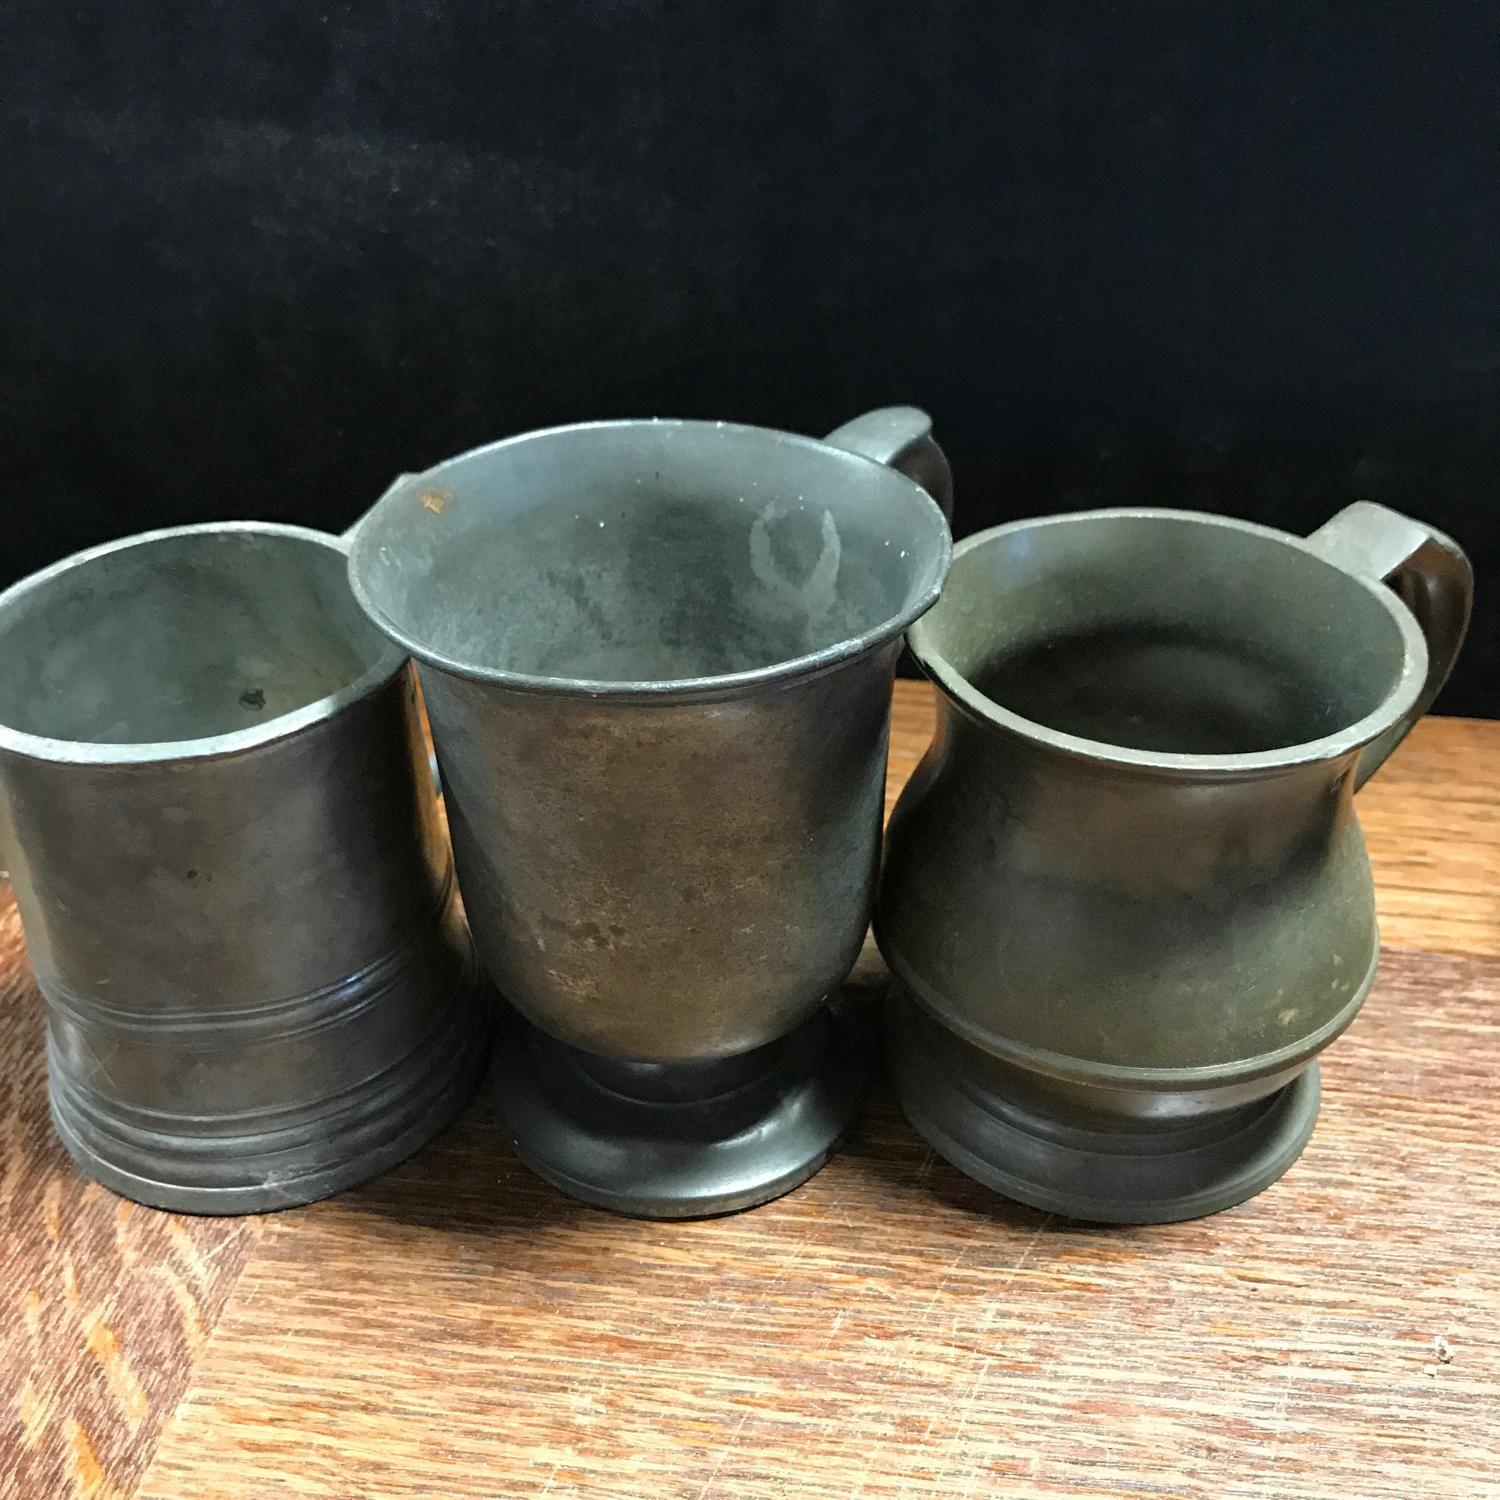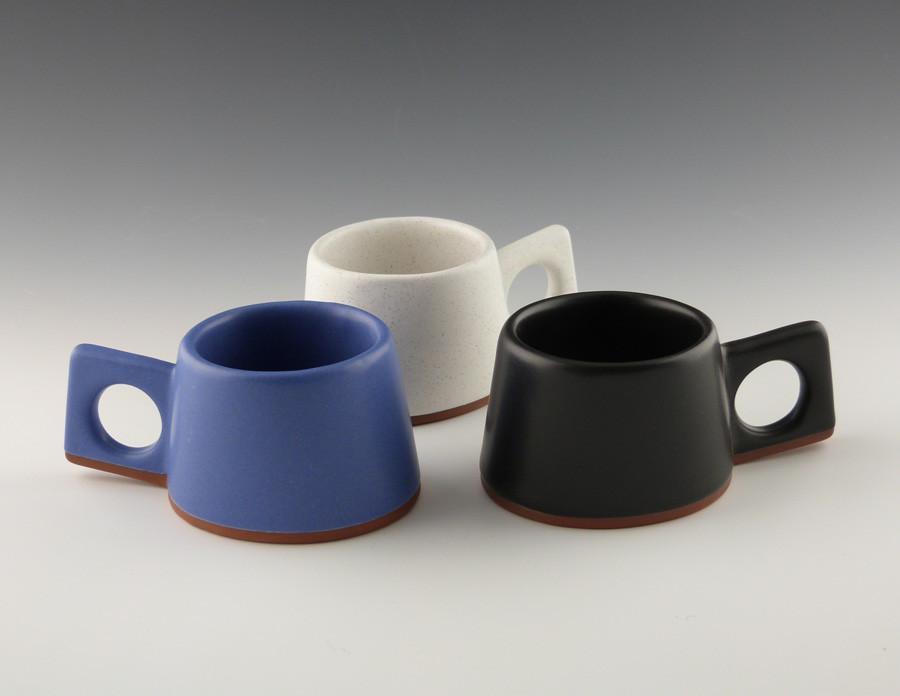The first image is the image on the left, the second image is the image on the right. Examine the images to the left and right. Is the description "There are exactly 6 cups, and no other objects." accurate? Answer yes or no. Yes. The first image is the image on the left, the second image is the image on the right. Analyze the images presented: Is the assertion "The image on the left shows three greenish mugs on a wooden table." valid? Answer yes or no. Yes. 